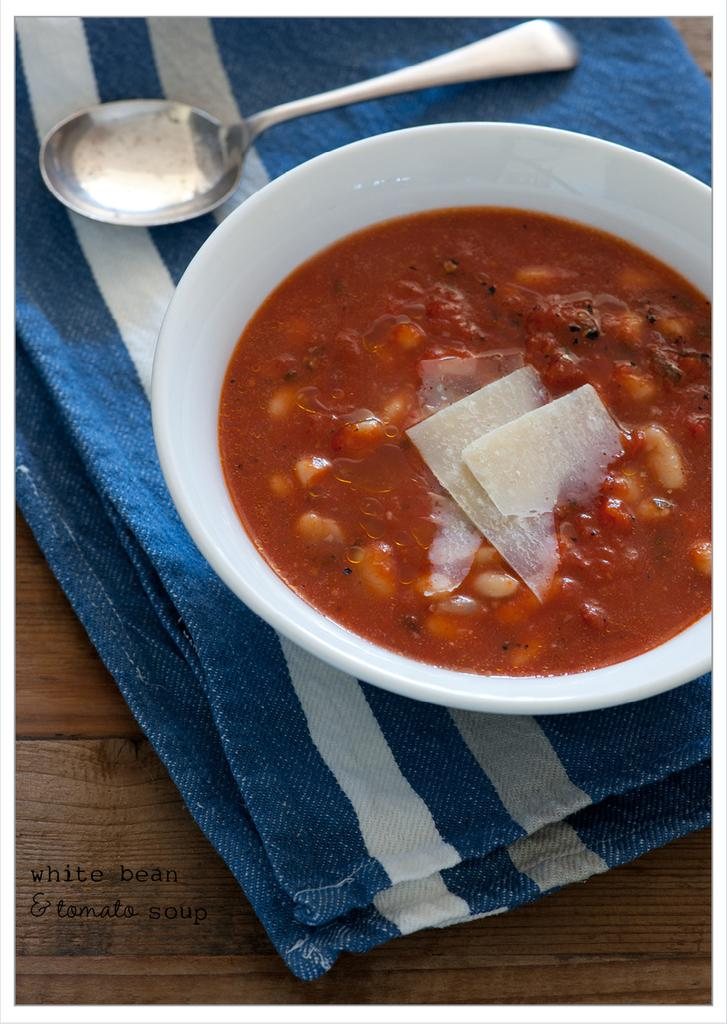What type of furniture is present in the image? There is a table in the image. What is covering the table? There is a cloth on the table. What utensil can be seen on the table? There is a spoon on the table. What is contained in a bowl on the table? There is food in a bowl on the table. What type of coast can be seen in the image? There is no coast present in the image; it features a table with a cloth, spoon, and food in a bowl. What is the sound of thunder like in the image? There is no mention of thunder or any sound in the image; it only shows a table with various items on it. 